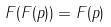Convert formula to latex. <formula><loc_0><loc_0><loc_500><loc_500>F ( F ( p ) ) = F ( p )</formula> 